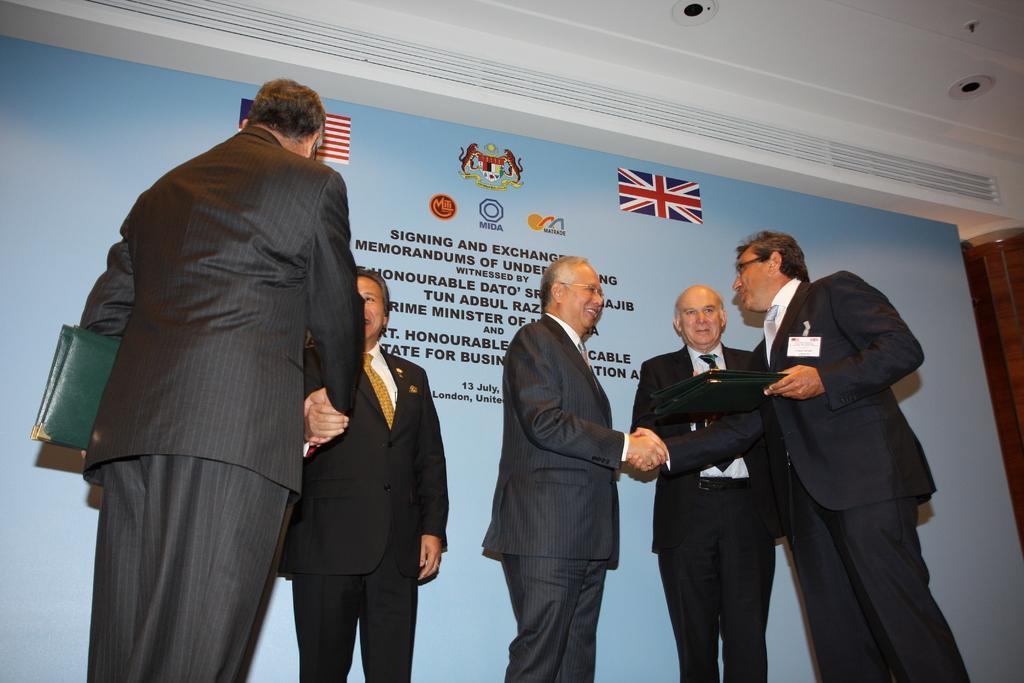In one or two sentences, can you explain what this image depicts? In this image, we can see people standing and wearing clothes. There are two persons holding files with their hands. There are lights in the top right of the image. 